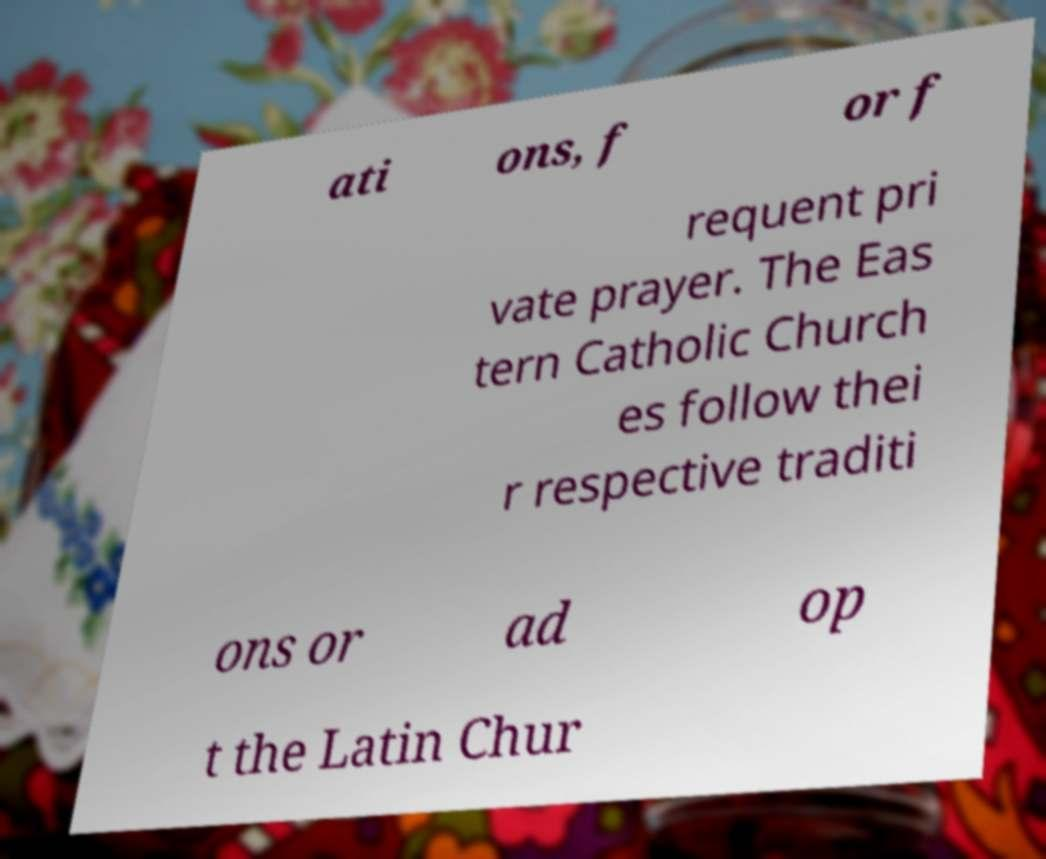Could you extract and type out the text from this image? ati ons, f or f requent pri vate prayer. The Eas tern Catholic Church es follow thei r respective traditi ons or ad op t the Latin Chur 